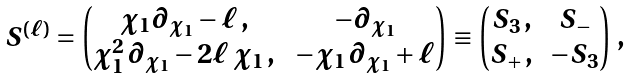Convert formula to latex. <formula><loc_0><loc_0><loc_500><loc_500>\begin{array} { c } S ^ { ( \ell ) } = \begin{pmatrix} \chi _ { 1 } \partial _ { \chi _ { 1 } } - \ell \, , & \, - \partial _ { \chi _ { 1 } } \\ \chi _ { 1 } ^ { 2 } \, \partial _ { \chi _ { 1 } } - 2 \ell \, \chi _ { 1 } \, , & \, - \chi _ { 1 } \, \partial _ { \chi _ { 1 } } + \ell \end{pmatrix} \equiv \begin{pmatrix} S _ { 3 } \, , & \, S _ { - } \\ S _ { + } \, , & - S _ { 3 } \end{pmatrix} \, , \end{array}</formula> 